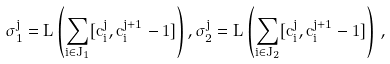<formula> <loc_0><loc_0><loc_500><loc_500>\sigma _ { 1 } ^ { j } = L \left ( \sum _ { i \in J _ { 1 } } [ c ^ { j } _ { i } , c ^ { j + 1 } _ { i } - 1 ] \right ) , \sigma _ { 2 } ^ { j } = L \left ( \sum _ { i \in J _ { 2 } } [ c ^ { j } _ { i } , c ^ { j + 1 } _ { i } - 1 ] \right ) \, ,</formula> 